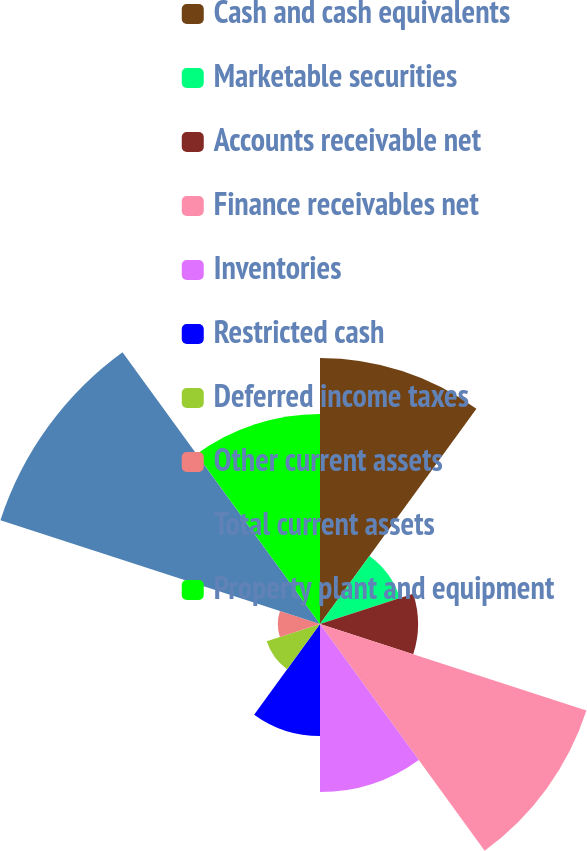Convert chart to OTSL. <chart><loc_0><loc_0><loc_500><loc_500><pie_chart><fcel>Cash and cash equivalents<fcel>Marketable securities<fcel>Accounts receivable net<fcel>Finance receivables net<fcel>Inventories<fcel>Restricted cash<fcel>Deferred income taxes<fcel>Other current assets<fcel>Total current assets<fcel>Property plant and equipment<nl><fcel>16.1%<fcel>5.09%<fcel>5.93%<fcel>16.95%<fcel>10.17%<fcel>6.78%<fcel>3.39%<fcel>2.55%<fcel>20.33%<fcel>12.71%<nl></chart> 